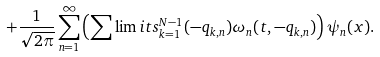<formula> <loc_0><loc_0><loc_500><loc_500>+ \frac { 1 } { \sqrt { 2 \pi } } \sum _ { n = 1 } ^ { \infty } \left ( \sum \lim i t s _ { k = 1 } ^ { N - 1 } ( - q _ { k , n } ) \omega _ { n } ( t , - q _ { k , n } ) \right ) \psi _ { n } ( x ) .</formula> 